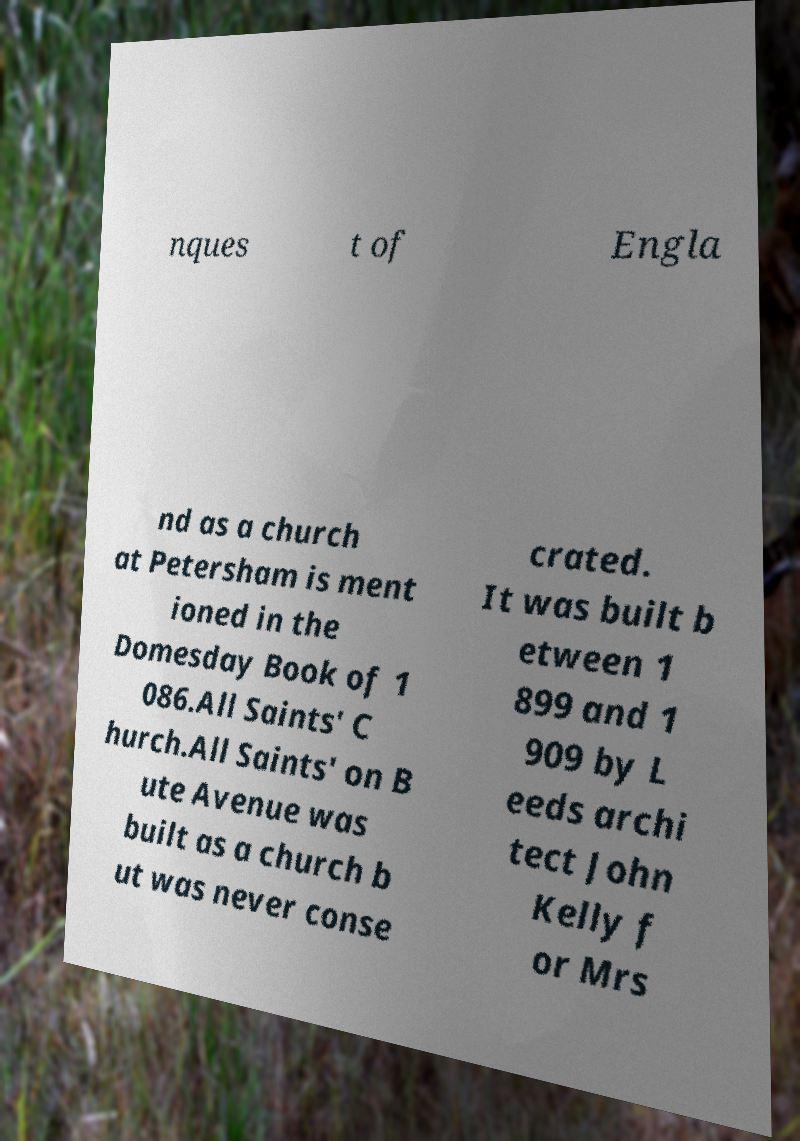There's text embedded in this image that I need extracted. Can you transcribe it verbatim? nques t of Engla nd as a church at Petersham is ment ioned in the Domesday Book of 1 086.All Saints' C hurch.All Saints' on B ute Avenue was built as a church b ut was never conse crated. It was built b etween 1 899 and 1 909 by L eeds archi tect John Kelly f or Mrs 